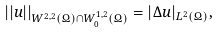<formula> <loc_0><loc_0><loc_500><loc_500>| | u | | _ { W ^ { 2 , 2 } ( \Omega ) \cap W ^ { 1 , 2 } _ { 0 } ( \Omega ) } = | \Delta u | _ { L ^ { 2 } ( \Omega ) } ,</formula> 